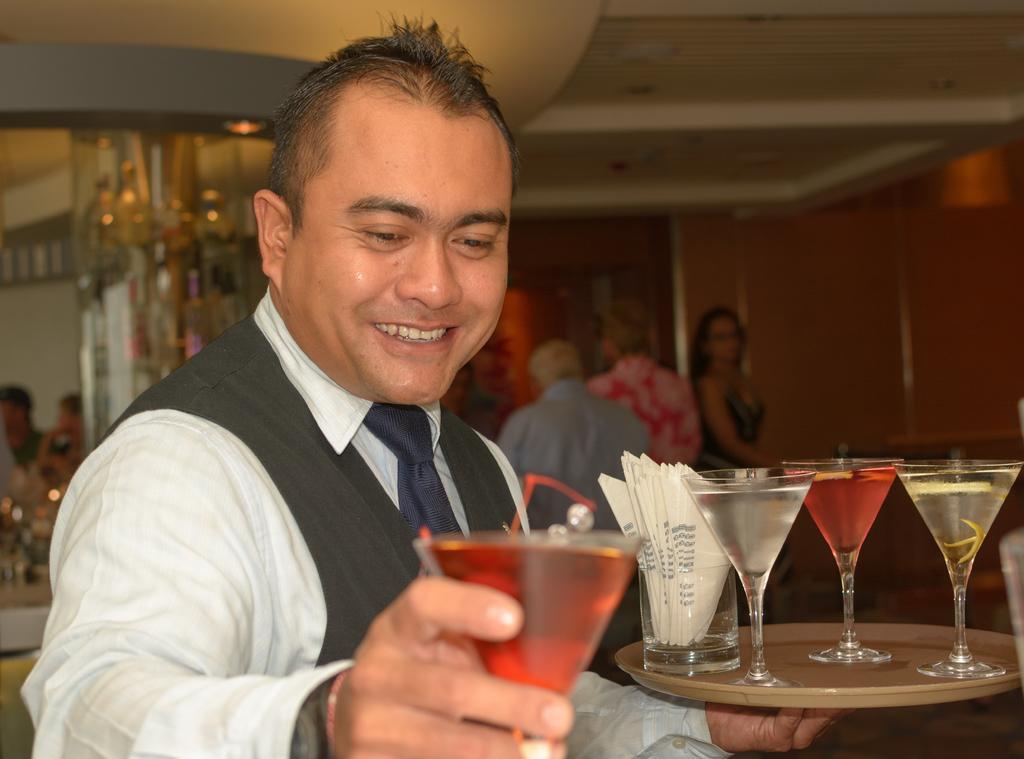Could you give a brief overview of what you see in this image? In this picture we can see a man holding a glass with drink init in his hand. We can see persons standing and sitting. This is a wall. this is a ceiling. 